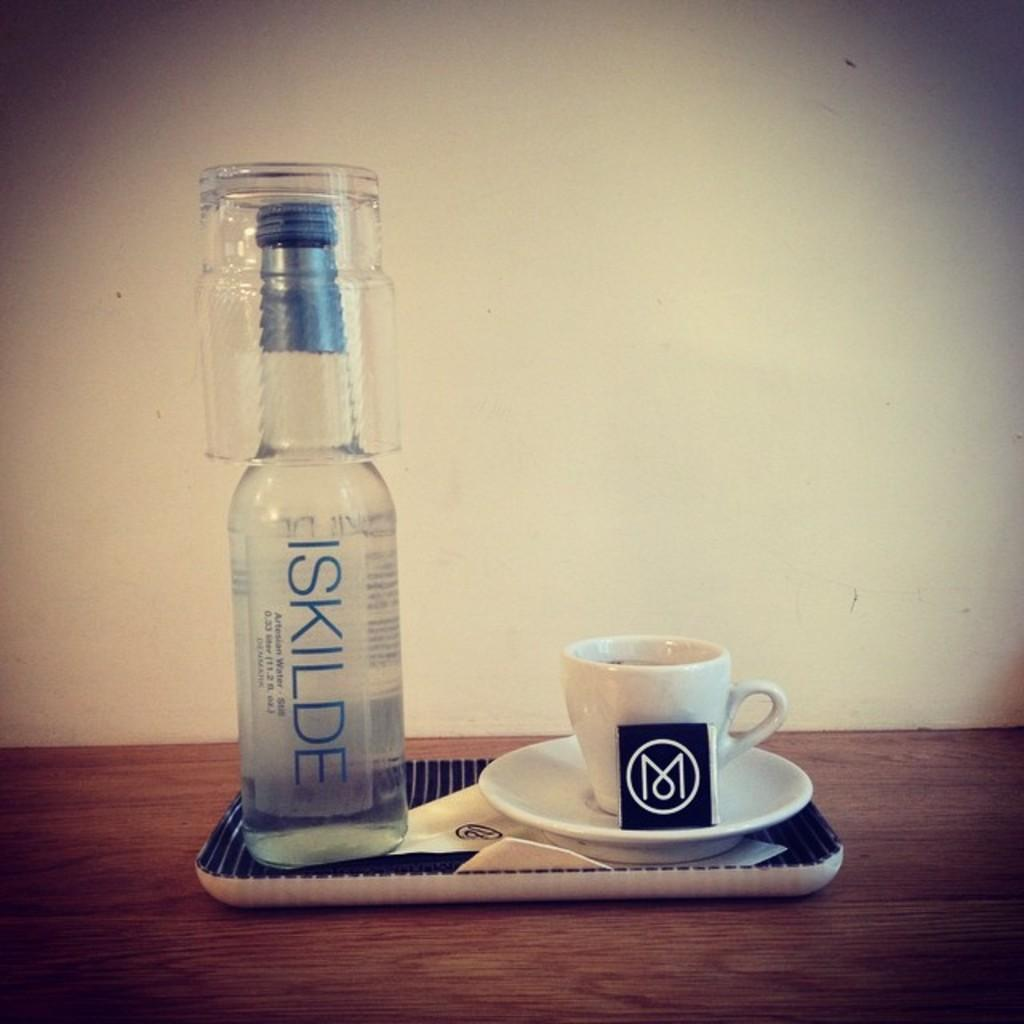<image>
Summarize the visual content of the image. a bottle of iskilde with a cup resting on the top of the bottle. 